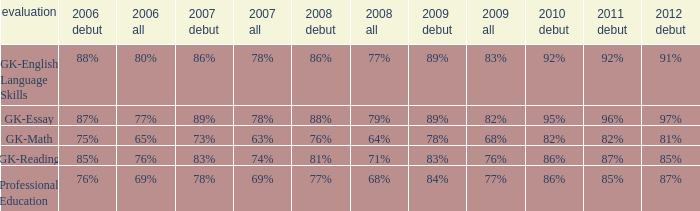What is the rate for all in 2007 when all in 2006 was 65%? 63%. Give me the full table as a dictionary. {'header': ['evaluation', '2006 debut', '2006 all', '2007 debut', '2007 all', '2008 debut', '2008 all', '2009 debut', '2009 all', '2010 debut', '2011 debut', '2012 debut'], 'rows': [['GK-English Language Skills', '88%', '80%', '86%', '78%', '86%', '77%', '89%', '83%', '92%', '92%', '91%'], ['GK-Essay', '87%', '77%', '89%', '78%', '88%', '79%', '89%', '82%', '95%', '96%', '97%'], ['GK-Math', '75%', '65%', '73%', '63%', '76%', '64%', '78%', '68%', '82%', '82%', '81%'], ['GK-Reading', '85%', '76%', '83%', '74%', '81%', '71%', '83%', '76%', '86%', '87%', '85%'], ['Professional Education', '76%', '69%', '78%', '69%', '77%', '68%', '84%', '77%', '86%', '85%', '87%']]} 